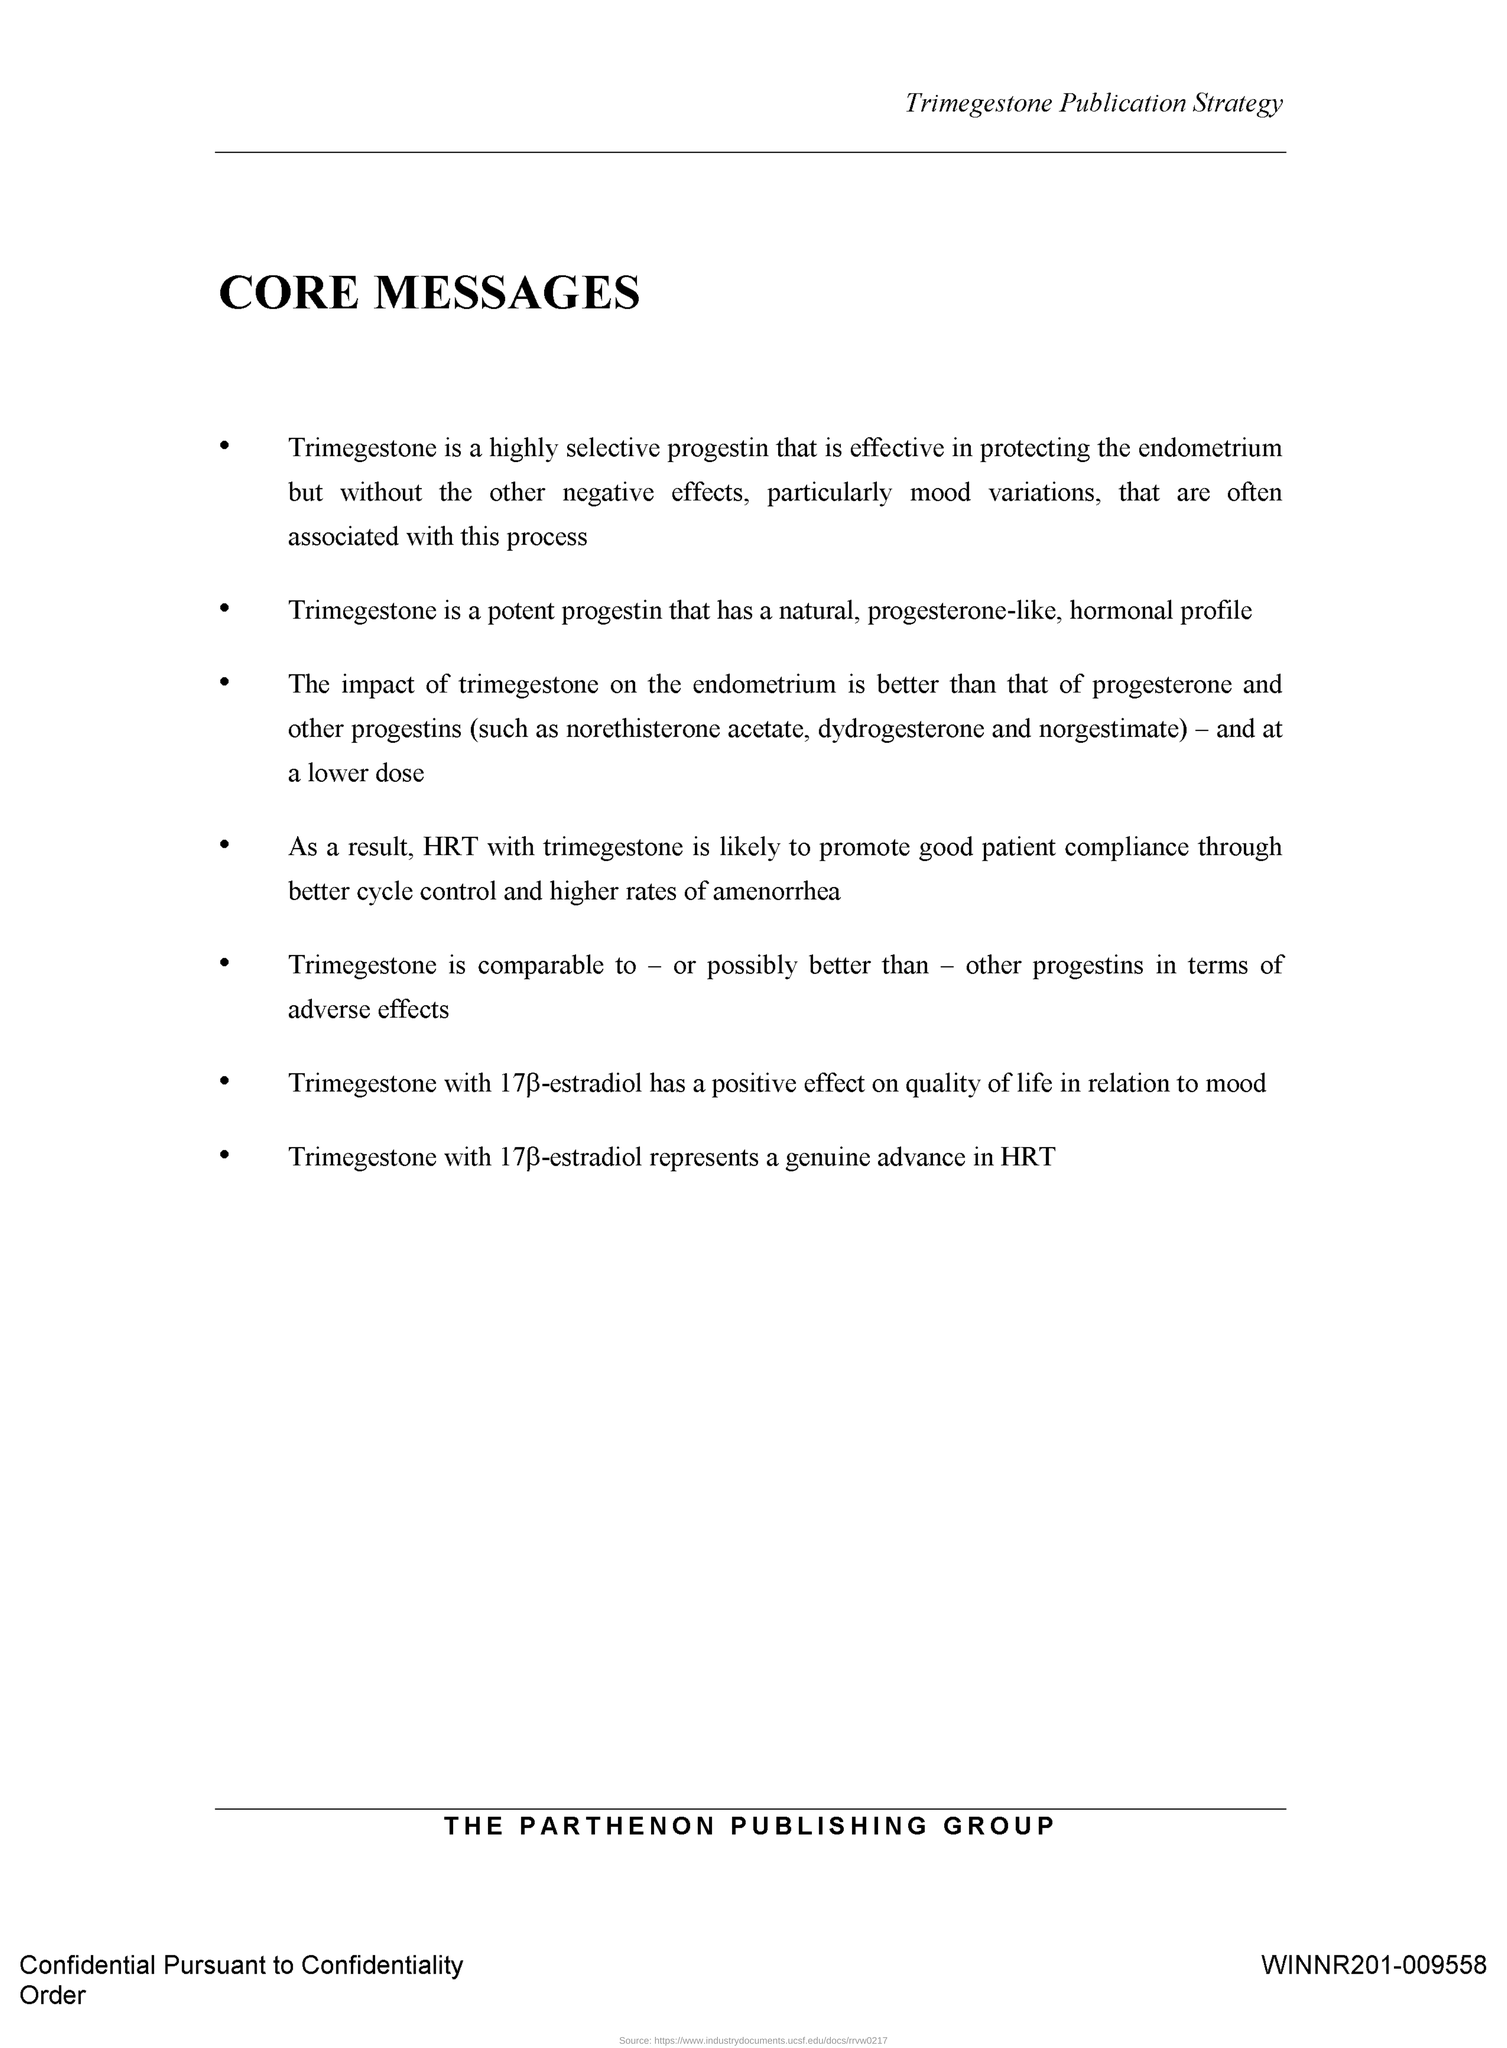Highlight a few significant elements in this photo. Trimegestone is a potent progestin that exhibits a natural, progesterone-like hormonal profile. It is used in hormone replacement therapy and as a contraceptive agent. The title of this document is 'CORE MESSAGES.' 